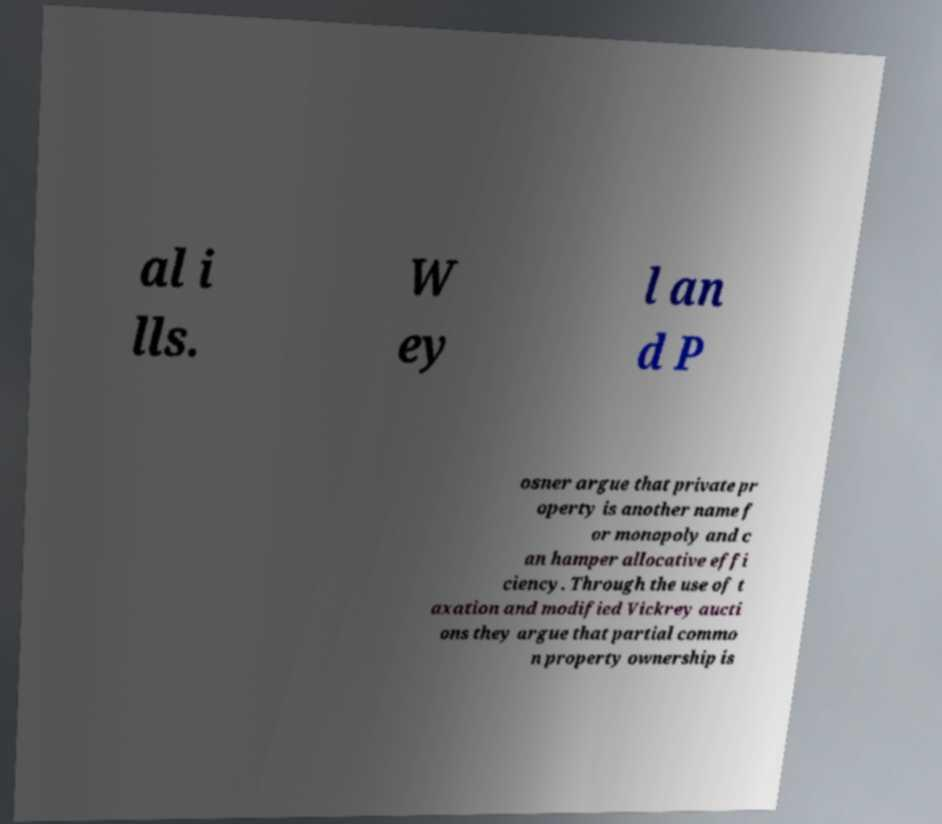Please read and relay the text visible in this image. What does it say? al i lls. W ey l an d P osner argue that private pr operty is another name f or monopoly and c an hamper allocative effi ciency. Through the use of t axation and modified Vickrey aucti ons they argue that partial commo n property ownership is 